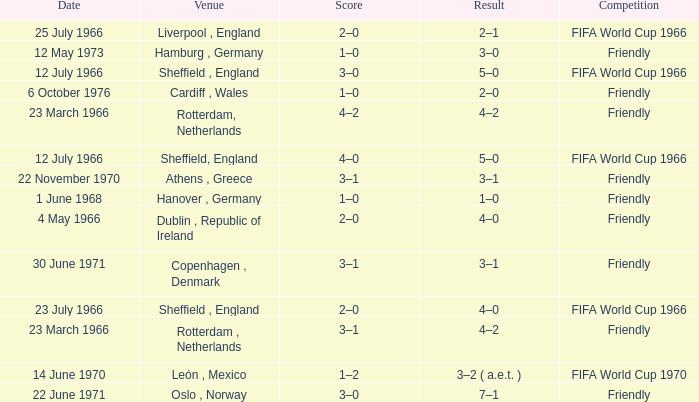Give me the full table as a dictionary. {'header': ['Date', 'Venue', 'Score', 'Result', 'Competition'], 'rows': [['25 July 1966', 'Liverpool , England', '2–0', '2–1', 'FIFA World Cup 1966'], ['12 May 1973', 'Hamburg , Germany', '1–0', '3–0', 'Friendly'], ['12 July 1966', 'Sheffield , England', '3–0', '5–0', 'FIFA World Cup 1966'], ['6 October 1976', 'Cardiff , Wales', '1–0', '2–0', 'Friendly'], ['23 March 1966', 'Rotterdam, Netherlands', '4–2', '4–2', 'Friendly'], ['12 July 1966', 'Sheffield, England', '4–0', '5–0', 'FIFA World Cup 1966'], ['22 November 1970', 'Athens , Greece', '3–1', '3–1', 'Friendly'], ['1 June 1968', 'Hanover , Germany', '1–0', '1–0', 'Friendly'], ['4 May 1966', 'Dublin , Republic of Ireland', '2–0', '4–0', 'Friendly'], ['30 June 1971', 'Copenhagen , Denmark', '3–1', '3–1', 'Friendly'], ['23 July 1966', 'Sheffield , England', '2–0', '4–0', 'FIFA World Cup 1966'], ['23 March 1966', 'Rotterdam , Netherlands', '3–1', '4–2', 'Friendly'], ['14 June 1970', 'León , Mexico', '1–2', '3–2 ( a.e.t. )', 'FIFA World Cup 1970'], ['22 June 1971', 'Oslo , Norway', '3–0', '7–1', 'Friendly']]} Which result's venue was in Rotterdam, Netherlands? 4–2, 4–2. 